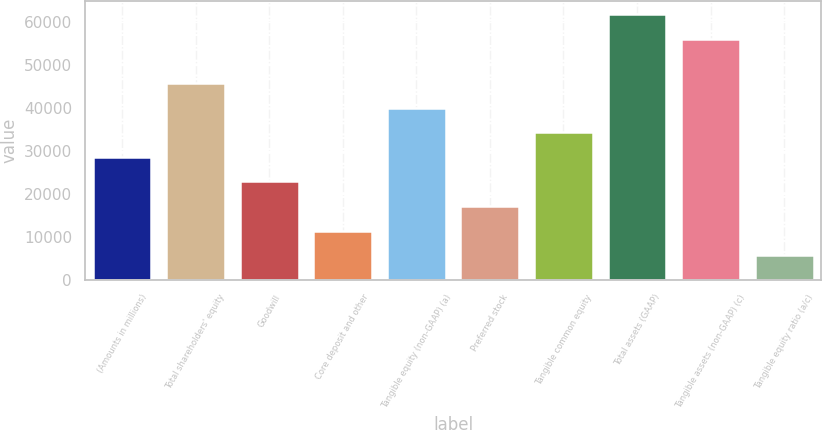Convert chart to OTSL. <chart><loc_0><loc_0><loc_500><loc_500><bar_chart><fcel>(Amounts in millions)<fcel>Total shareholders' equity<fcel>Goodwill<fcel>Core deposit and other<fcel>Tangible equity (non-GAAP) (a)<fcel>Preferred stock<fcel>Tangible common equity<fcel>Total assets (GAAP)<fcel>Tangible assets (non-GAAP) (c)<fcel>Tangible equity ratio (a/c)<nl><fcel>28609.2<fcel>45769.1<fcel>22889.3<fcel>11449.4<fcel>40049.1<fcel>17169.3<fcel>34329.2<fcel>61888.9<fcel>56169<fcel>5729.43<nl></chart> 